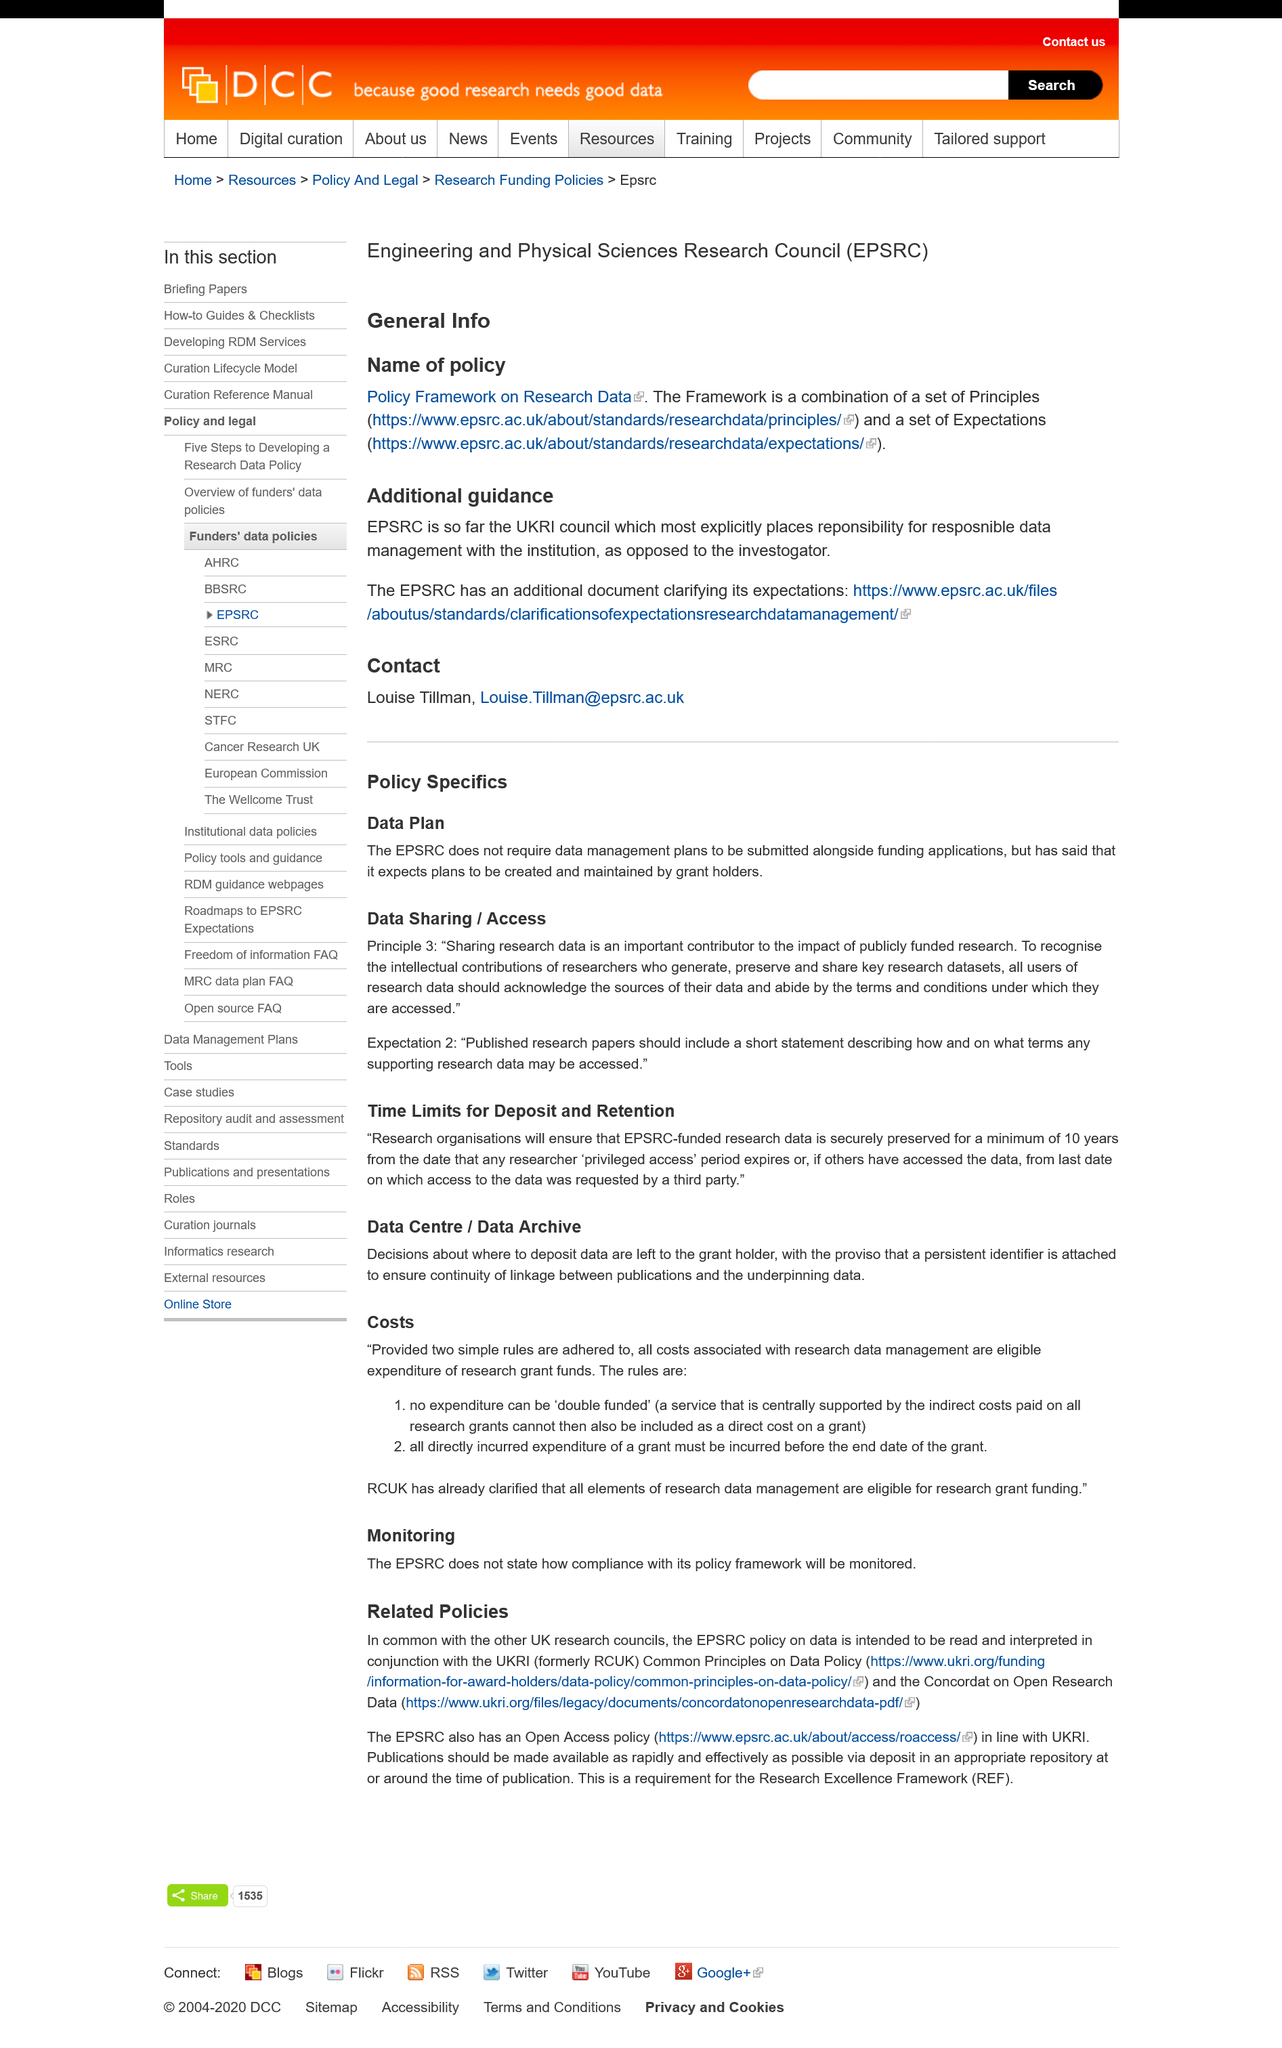List a handful of essential elements in this visual. The EPSRC does not require data management plans, but the EPSRC requires data management plans. The title of this page is "Policy Specifics". 